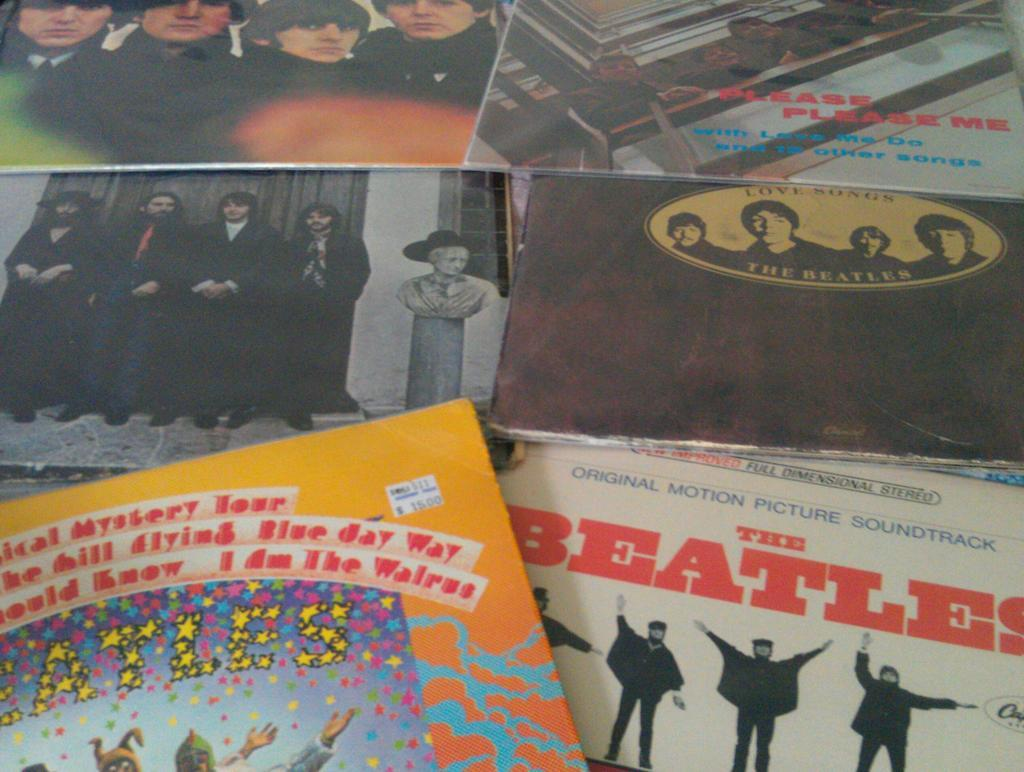<image>
Relay a brief, clear account of the picture shown. Several Beatles album covers are lying on top of each other including Magical Mystery Tour and Please Please Me. 